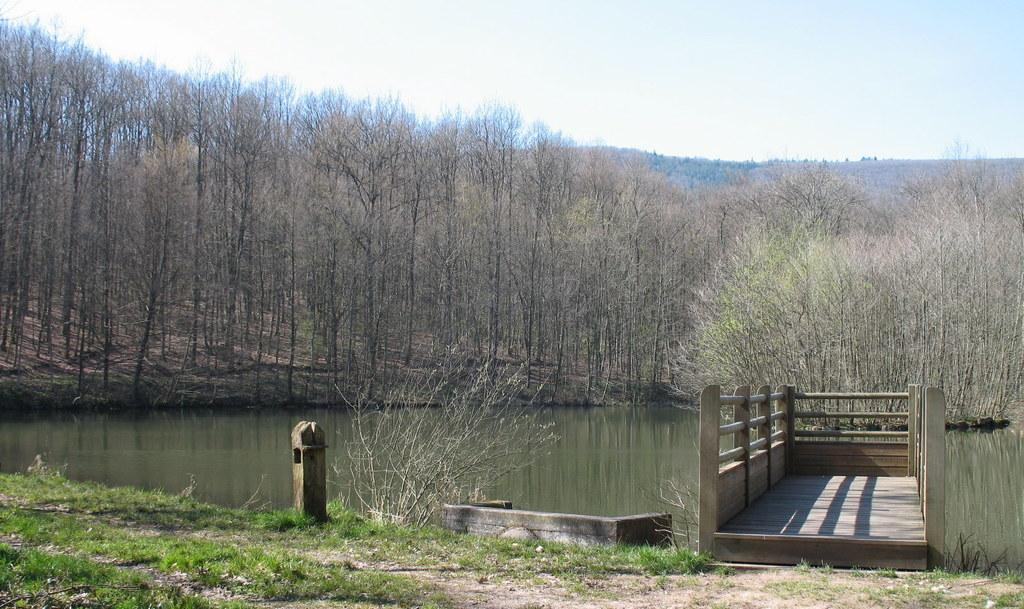What type of vegetation can be seen in the image? There are trees in the image. What else can be seen besides trees in the image? There is water visible in the image, as well as grass on the ground. What structure is present in the image? There is a wooden bridge in the image. How would you describe the sky in the image? The sky is cloudy in the image. Where is the key located on the shelf in the image? There is no key or shelf present in the image. What type of pail can be seen near the water in the image? There is no pail visible in the image; only trees, water, grass, a wooden bridge, and a cloudy sky are present. 